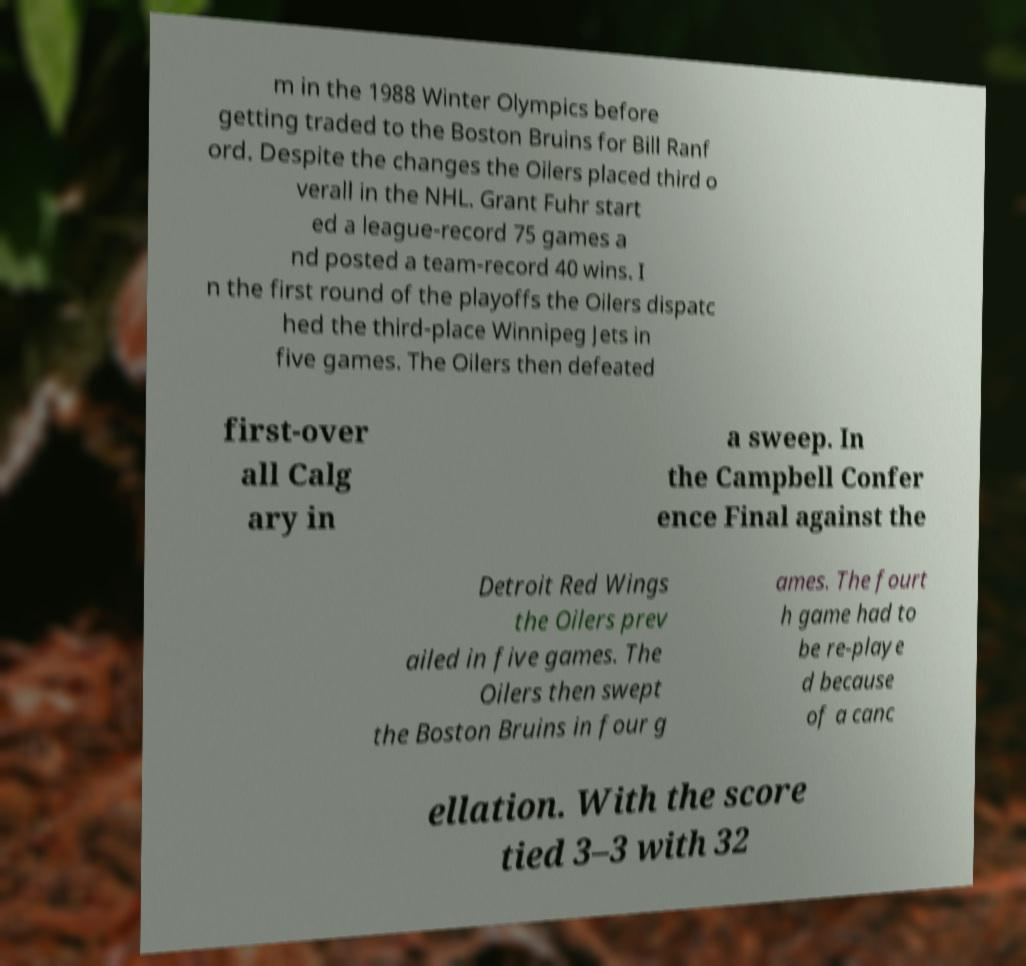Can you read and provide the text displayed in the image?This photo seems to have some interesting text. Can you extract and type it out for me? m in the 1988 Winter Olympics before getting traded to the Boston Bruins for Bill Ranf ord. Despite the changes the Oilers placed third o verall in the NHL. Grant Fuhr start ed a league-record 75 games a nd posted a team-record 40 wins. I n the first round of the playoffs the Oilers dispatc hed the third-place Winnipeg Jets in five games. The Oilers then defeated first-over all Calg ary in a sweep. In the Campbell Confer ence Final against the Detroit Red Wings the Oilers prev ailed in five games. The Oilers then swept the Boston Bruins in four g ames. The fourt h game had to be re-playe d because of a canc ellation. With the score tied 3–3 with 32 